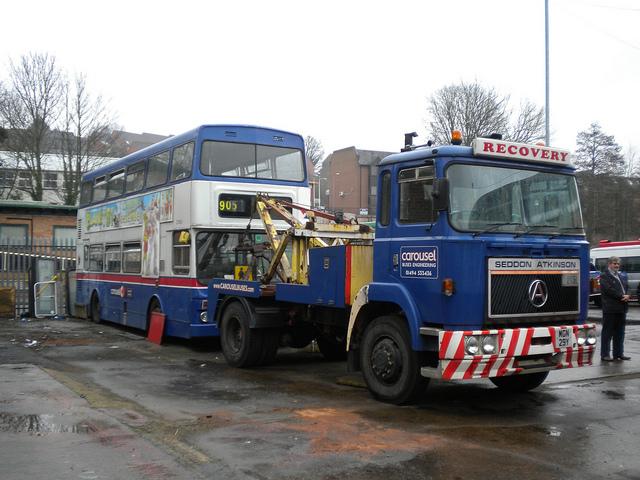Is this truck used in emergencies?
Give a very brief answer. Yes. What type of truck is this?
Short answer required. Tow truck. Has it been raining?
Write a very short answer. Yes. What type of vehicle is this?
Be succinct. Truck. Are the trucks parked in a paved lot?
Short answer required. Yes. What color is this truck?
Concise answer only. Blue. What is the truck looking ready to tow?
Answer briefly. Bus. 